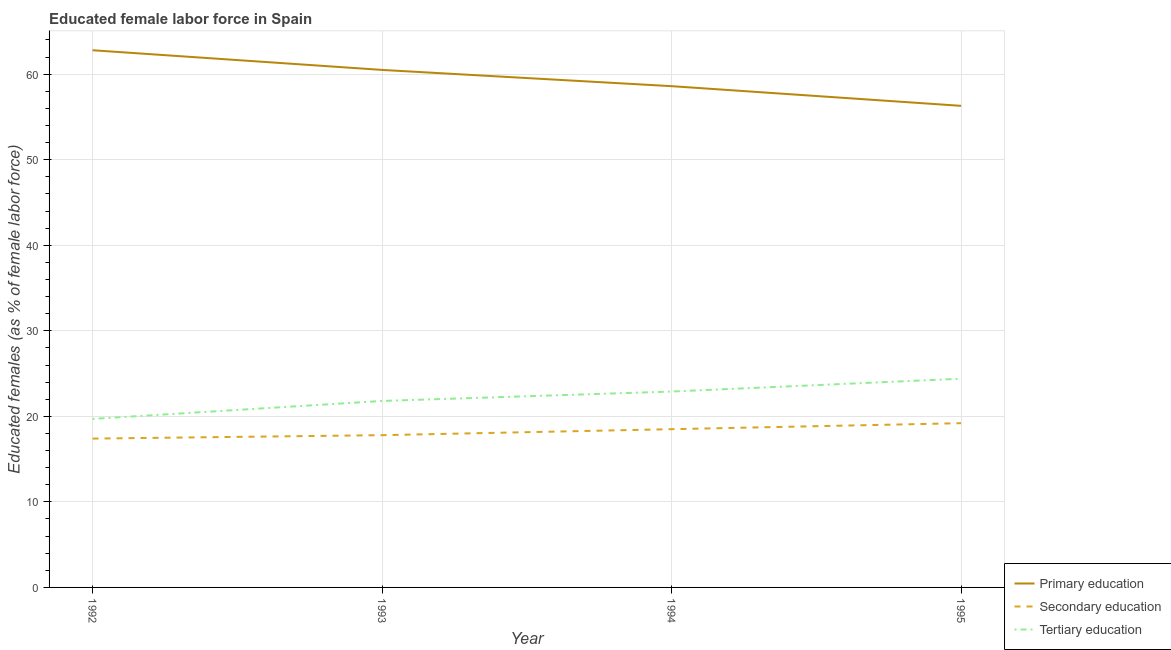Does the line corresponding to percentage of female labor force who received primary education intersect with the line corresponding to percentage of female labor force who received tertiary education?
Give a very brief answer. No. What is the percentage of female labor force who received tertiary education in 1992?
Your answer should be very brief. 19.7. Across all years, what is the maximum percentage of female labor force who received primary education?
Keep it short and to the point. 62.8. Across all years, what is the minimum percentage of female labor force who received tertiary education?
Your answer should be very brief. 19.7. In which year was the percentage of female labor force who received secondary education maximum?
Offer a very short reply. 1995. In which year was the percentage of female labor force who received secondary education minimum?
Provide a succinct answer. 1992. What is the total percentage of female labor force who received tertiary education in the graph?
Your response must be concise. 88.8. What is the difference between the percentage of female labor force who received secondary education in 1993 and that in 1995?
Give a very brief answer. -1.4. What is the difference between the percentage of female labor force who received tertiary education in 1994 and the percentage of female labor force who received primary education in 1992?
Give a very brief answer. -39.9. What is the average percentage of female labor force who received primary education per year?
Provide a succinct answer. 59.55. In the year 1994, what is the difference between the percentage of female labor force who received secondary education and percentage of female labor force who received tertiary education?
Your response must be concise. -4.4. What is the ratio of the percentage of female labor force who received primary education in 1993 to that in 1994?
Your answer should be compact. 1.03. What is the difference between the highest and the second highest percentage of female labor force who received secondary education?
Keep it short and to the point. 0.7. What is the difference between the highest and the lowest percentage of female labor force who received primary education?
Give a very brief answer. 6.5. In how many years, is the percentage of female labor force who received primary education greater than the average percentage of female labor force who received primary education taken over all years?
Ensure brevity in your answer.  2. Is it the case that in every year, the sum of the percentage of female labor force who received primary education and percentage of female labor force who received secondary education is greater than the percentage of female labor force who received tertiary education?
Provide a succinct answer. Yes. Is the percentage of female labor force who received primary education strictly greater than the percentage of female labor force who received tertiary education over the years?
Provide a succinct answer. Yes. Is the percentage of female labor force who received tertiary education strictly less than the percentage of female labor force who received secondary education over the years?
Provide a short and direct response. No. How many lines are there?
Make the answer very short. 3. How many years are there in the graph?
Your answer should be very brief. 4. Are the values on the major ticks of Y-axis written in scientific E-notation?
Keep it short and to the point. No. Does the graph contain any zero values?
Provide a succinct answer. No. Where does the legend appear in the graph?
Provide a short and direct response. Bottom right. How are the legend labels stacked?
Give a very brief answer. Vertical. What is the title of the graph?
Make the answer very short. Educated female labor force in Spain. Does "Services" appear as one of the legend labels in the graph?
Offer a very short reply. No. What is the label or title of the Y-axis?
Provide a succinct answer. Educated females (as % of female labor force). What is the Educated females (as % of female labor force) in Primary education in 1992?
Provide a succinct answer. 62.8. What is the Educated females (as % of female labor force) of Secondary education in 1992?
Your response must be concise. 17.4. What is the Educated females (as % of female labor force) in Tertiary education in 1992?
Your answer should be compact. 19.7. What is the Educated females (as % of female labor force) of Primary education in 1993?
Give a very brief answer. 60.5. What is the Educated females (as % of female labor force) of Secondary education in 1993?
Ensure brevity in your answer.  17.8. What is the Educated females (as % of female labor force) in Tertiary education in 1993?
Ensure brevity in your answer.  21.8. What is the Educated females (as % of female labor force) of Primary education in 1994?
Provide a short and direct response. 58.6. What is the Educated females (as % of female labor force) of Secondary education in 1994?
Offer a very short reply. 18.5. What is the Educated females (as % of female labor force) of Tertiary education in 1994?
Your answer should be very brief. 22.9. What is the Educated females (as % of female labor force) of Primary education in 1995?
Provide a short and direct response. 56.3. What is the Educated females (as % of female labor force) of Secondary education in 1995?
Keep it short and to the point. 19.2. What is the Educated females (as % of female labor force) in Tertiary education in 1995?
Keep it short and to the point. 24.4. Across all years, what is the maximum Educated females (as % of female labor force) in Primary education?
Offer a terse response. 62.8. Across all years, what is the maximum Educated females (as % of female labor force) in Secondary education?
Give a very brief answer. 19.2. Across all years, what is the maximum Educated females (as % of female labor force) of Tertiary education?
Your answer should be compact. 24.4. Across all years, what is the minimum Educated females (as % of female labor force) in Primary education?
Your answer should be compact. 56.3. Across all years, what is the minimum Educated females (as % of female labor force) of Secondary education?
Offer a very short reply. 17.4. Across all years, what is the minimum Educated females (as % of female labor force) of Tertiary education?
Your response must be concise. 19.7. What is the total Educated females (as % of female labor force) in Primary education in the graph?
Offer a very short reply. 238.2. What is the total Educated females (as % of female labor force) of Secondary education in the graph?
Offer a terse response. 72.9. What is the total Educated females (as % of female labor force) in Tertiary education in the graph?
Your answer should be compact. 88.8. What is the difference between the Educated females (as % of female labor force) of Primary education in 1992 and that in 1993?
Your answer should be very brief. 2.3. What is the difference between the Educated females (as % of female labor force) of Tertiary education in 1992 and that in 1993?
Offer a very short reply. -2.1. What is the difference between the Educated females (as % of female labor force) of Primary education in 1992 and that in 1995?
Provide a short and direct response. 6.5. What is the difference between the Educated females (as % of female labor force) in Primary education in 1993 and that in 1994?
Provide a short and direct response. 1.9. What is the difference between the Educated females (as % of female labor force) in Tertiary education in 1993 and that in 1994?
Keep it short and to the point. -1.1. What is the difference between the Educated females (as % of female labor force) of Tertiary education in 1993 and that in 1995?
Your response must be concise. -2.6. What is the difference between the Educated females (as % of female labor force) in Primary education in 1994 and that in 1995?
Make the answer very short. 2.3. What is the difference between the Educated females (as % of female labor force) in Secondary education in 1994 and that in 1995?
Provide a succinct answer. -0.7. What is the difference between the Educated females (as % of female labor force) in Primary education in 1992 and the Educated females (as % of female labor force) in Secondary education in 1993?
Provide a short and direct response. 45. What is the difference between the Educated females (as % of female labor force) in Secondary education in 1992 and the Educated females (as % of female labor force) in Tertiary education in 1993?
Your answer should be compact. -4.4. What is the difference between the Educated females (as % of female labor force) in Primary education in 1992 and the Educated females (as % of female labor force) in Secondary education in 1994?
Your answer should be very brief. 44.3. What is the difference between the Educated females (as % of female labor force) in Primary education in 1992 and the Educated females (as % of female labor force) in Tertiary education in 1994?
Offer a very short reply. 39.9. What is the difference between the Educated females (as % of female labor force) in Secondary education in 1992 and the Educated females (as % of female labor force) in Tertiary education in 1994?
Offer a very short reply. -5.5. What is the difference between the Educated females (as % of female labor force) in Primary education in 1992 and the Educated females (as % of female labor force) in Secondary education in 1995?
Your answer should be very brief. 43.6. What is the difference between the Educated females (as % of female labor force) in Primary education in 1992 and the Educated females (as % of female labor force) in Tertiary education in 1995?
Offer a terse response. 38.4. What is the difference between the Educated females (as % of female labor force) of Secondary education in 1992 and the Educated females (as % of female labor force) of Tertiary education in 1995?
Make the answer very short. -7. What is the difference between the Educated females (as % of female labor force) of Primary education in 1993 and the Educated females (as % of female labor force) of Secondary education in 1994?
Ensure brevity in your answer.  42. What is the difference between the Educated females (as % of female labor force) in Primary education in 1993 and the Educated females (as % of female labor force) in Tertiary education in 1994?
Your response must be concise. 37.6. What is the difference between the Educated females (as % of female labor force) in Primary education in 1993 and the Educated females (as % of female labor force) in Secondary education in 1995?
Make the answer very short. 41.3. What is the difference between the Educated females (as % of female labor force) in Primary education in 1993 and the Educated females (as % of female labor force) in Tertiary education in 1995?
Offer a terse response. 36.1. What is the difference between the Educated females (as % of female labor force) in Primary education in 1994 and the Educated females (as % of female labor force) in Secondary education in 1995?
Offer a very short reply. 39.4. What is the difference between the Educated females (as % of female labor force) of Primary education in 1994 and the Educated females (as % of female labor force) of Tertiary education in 1995?
Provide a succinct answer. 34.2. What is the difference between the Educated females (as % of female labor force) in Secondary education in 1994 and the Educated females (as % of female labor force) in Tertiary education in 1995?
Keep it short and to the point. -5.9. What is the average Educated females (as % of female labor force) of Primary education per year?
Make the answer very short. 59.55. What is the average Educated females (as % of female labor force) in Secondary education per year?
Your response must be concise. 18.23. What is the average Educated females (as % of female labor force) of Tertiary education per year?
Your response must be concise. 22.2. In the year 1992, what is the difference between the Educated females (as % of female labor force) in Primary education and Educated females (as % of female labor force) in Secondary education?
Your answer should be very brief. 45.4. In the year 1992, what is the difference between the Educated females (as % of female labor force) in Primary education and Educated females (as % of female labor force) in Tertiary education?
Offer a terse response. 43.1. In the year 1993, what is the difference between the Educated females (as % of female labor force) of Primary education and Educated females (as % of female labor force) of Secondary education?
Offer a terse response. 42.7. In the year 1993, what is the difference between the Educated females (as % of female labor force) of Primary education and Educated females (as % of female labor force) of Tertiary education?
Keep it short and to the point. 38.7. In the year 1993, what is the difference between the Educated females (as % of female labor force) of Secondary education and Educated females (as % of female labor force) of Tertiary education?
Your answer should be very brief. -4. In the year 1994, what is the difference between the Educated females (as % of female labor force) in Primary education and Educated females (as % of female labor force) in Secondary education?
Your response must be concise. 40.1. In the year 1994, what is the difference between the Educated females (as % of female labor force) in Primary education and Educated females (as % of female labor force) in Tertiary education?
Your response must be concise. 35.7. In the year 1995, what is the difference between the Educated females (as % of female labor force) in Primary education and Educated females (as % of female labor force) in Secondary education?
Provide a succinct answer. 37.1. In the year 1995, what is the difference between the Educated females (as % of female labor force) of Primary education and Educated females (as % of female labor force) of Tertiary education?
Your answer should be very brief. 31.9. In the year 1995, what is the difference between the Educated females (as % of female labor force) of Secondary education and Educated females (as % of female labor force) of Tertiary education?
Offer a terse response. -5.2. What is the ratio of the Educated females (as % of female labor force) of Primary education in 1992 to that in 1993?
Your answer should be very brief. 1.04. What is the ratio of the Educated females (as % of female labor force) of Secondary education in 1992 to that in 1993?
Your response must be concise. 0.98. What is the ratio of the Educated females (as % of female labor force) in Tertiary education in 1992 to that in 1993?
Offer a very short reply. 0.9. What is the ratio of the Educated females (as % of female labor force) in Primary education in 1992 to that in 1994?
Provide a succinct answer. 1.07. What is the ratio of the Educated females (as % of female labor force) in Secondary education in 1992 to that in 1994?
Provide a short and direct response. 0.94. What is the ratio of the Educated females (as % of female labor force) in Tertiary education in 1992 to that in 1994?
Provide a succinct answer. 0.86. What is the ratio of the Educated females (as % of female labor force) of Primary education in 1992 to that in 1995?
Offer a very short reply. 1.12. What is the ratio of the Educated females (as % of female labor force) of Secondary education in 1992 to that in 1995?
Ensure brevity in your answer.  0.91. What is the ratio of the Educated females (as % of female labor force) in Tertiary education in 1992 to that in 1995?
Ensure brevity in your answer.  0.81. What is the ratio of the Educated females (as % of female labor force) in Primary education in 1993 to that in 1994?
Make the answer very short. 1.03. What is the ratio of the Educated females (as % of female labor force) in Secondary education in 1993 to that in 1994?
Provide a succinct answer. 0.96. What is the ratio of the Educated females (as % of female labor force) in Tertiary education in 1993 to that in 1994?
Offer a very short reply. 0.95. What is the ratio of the Educated females (as % of female labor force) in Primary education in 1993 to that in 1995?
Offer a terse response. 1.07. What is the ratio of the Educated females (as % of female labor force) of Secondary education in 1993 to that in 1995?
Provide a succinct answer. 0.93. What is the ratio of the Educated females (as % of female labor force) of Tertiary education in 1993 to that in 1995?
Offer a very short reply. 0.89. What is the ratio of the Educated females (as % of female labor force) of Primary education in 1994 to that in 1995?
Provide a short and direct response. 1.04. What is the ratio of the Educated females (as % of female labor force) of Secondary education in 1994 to that in 1995?
Offer a terse response. 0.96. What is the ratio of the Educated females (as % of female labor force) of Tertiary education in 1994 to that in 1995?
Ensure brevity in your answer.  0.94. What is the difference between the highest and the second highest Educated females (as % of female labor force) in Primary education?
Your answer should be very brief. 2.3. What is the difference between the highest and the second highest Educated females (as % of female labor force) in Tertiary education?
Offer a very short reply. 1.5. 